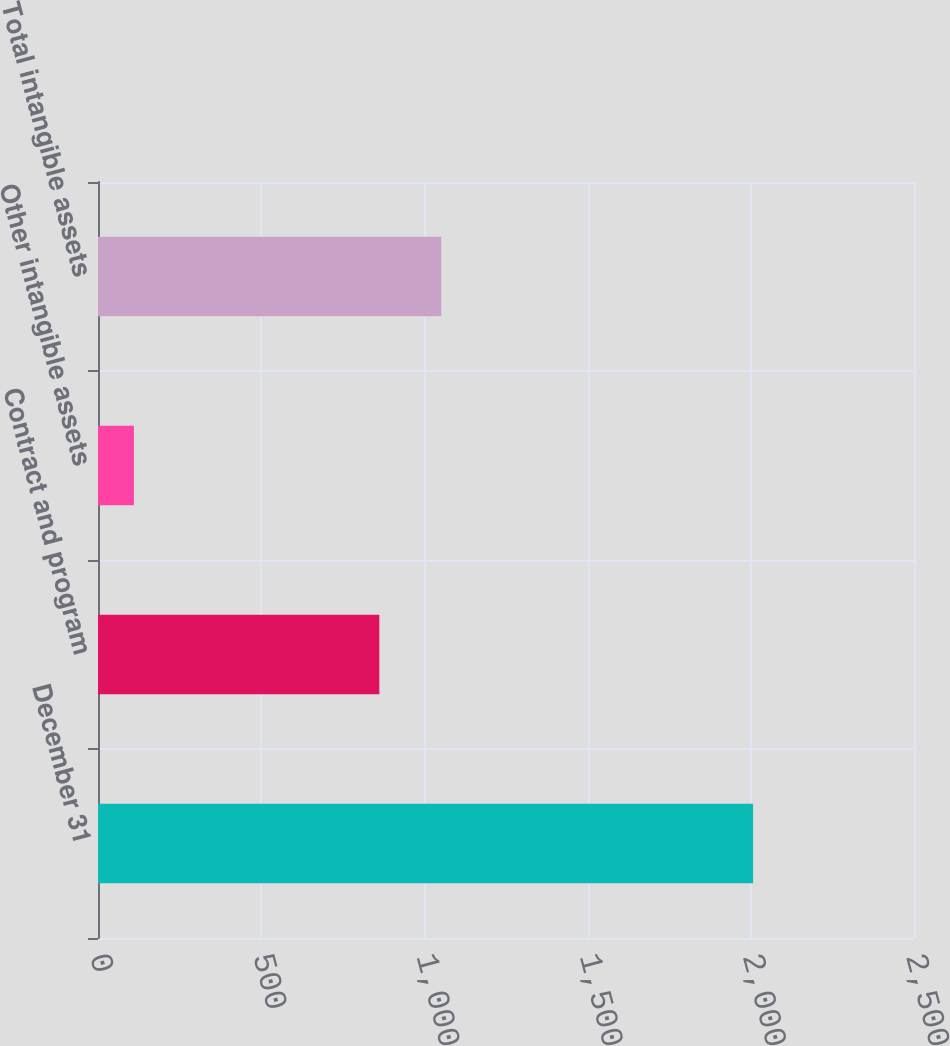<chart> <loc_0><loc_0><loc_500><loc_500><bar_chart><fcel>December 31<fcel>Contract and program<fcel>Other intangible assets<fcel>Total intangible assets<nl><fcel>2007<fcel>862<fcel>110<fcel>1051.7<nl></chart> 